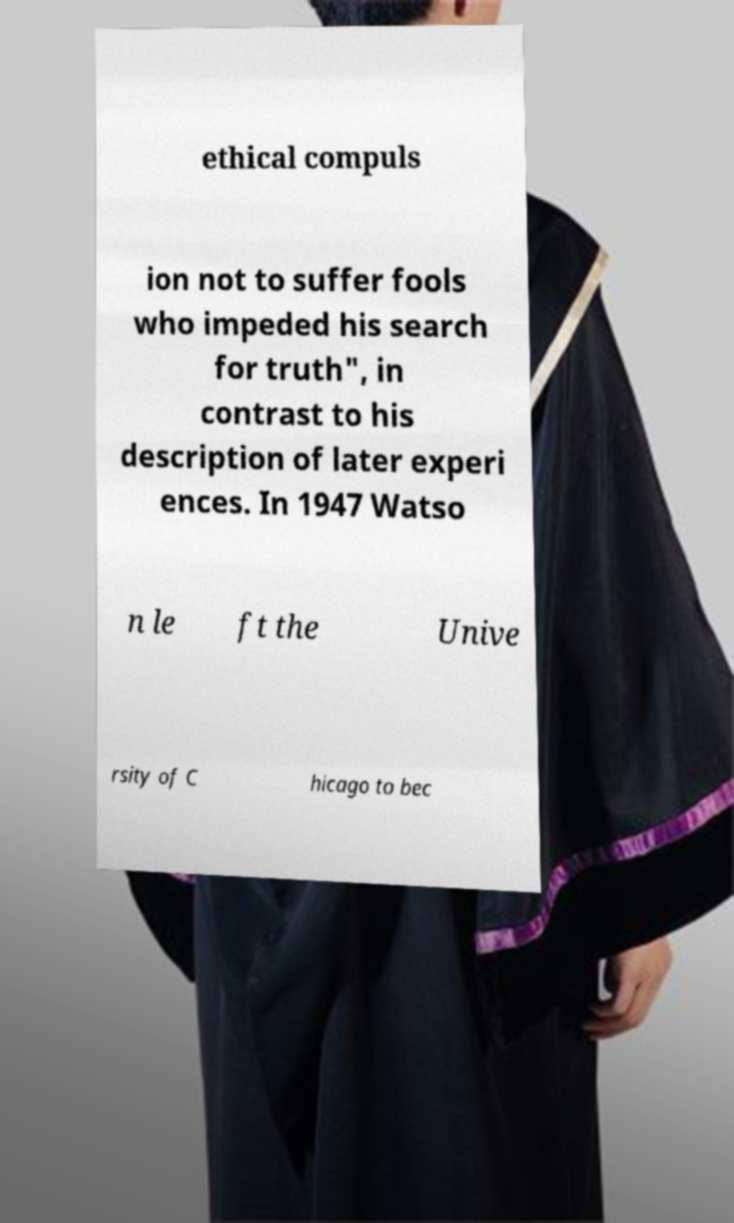Could you extract and type out the text from this image? ethical compuls ion not to suffer fools who impeded his search for truth", in contrast to his description of later experi ences. In 1947 Watso n le ft the Unive rsity of C hicago to bec 